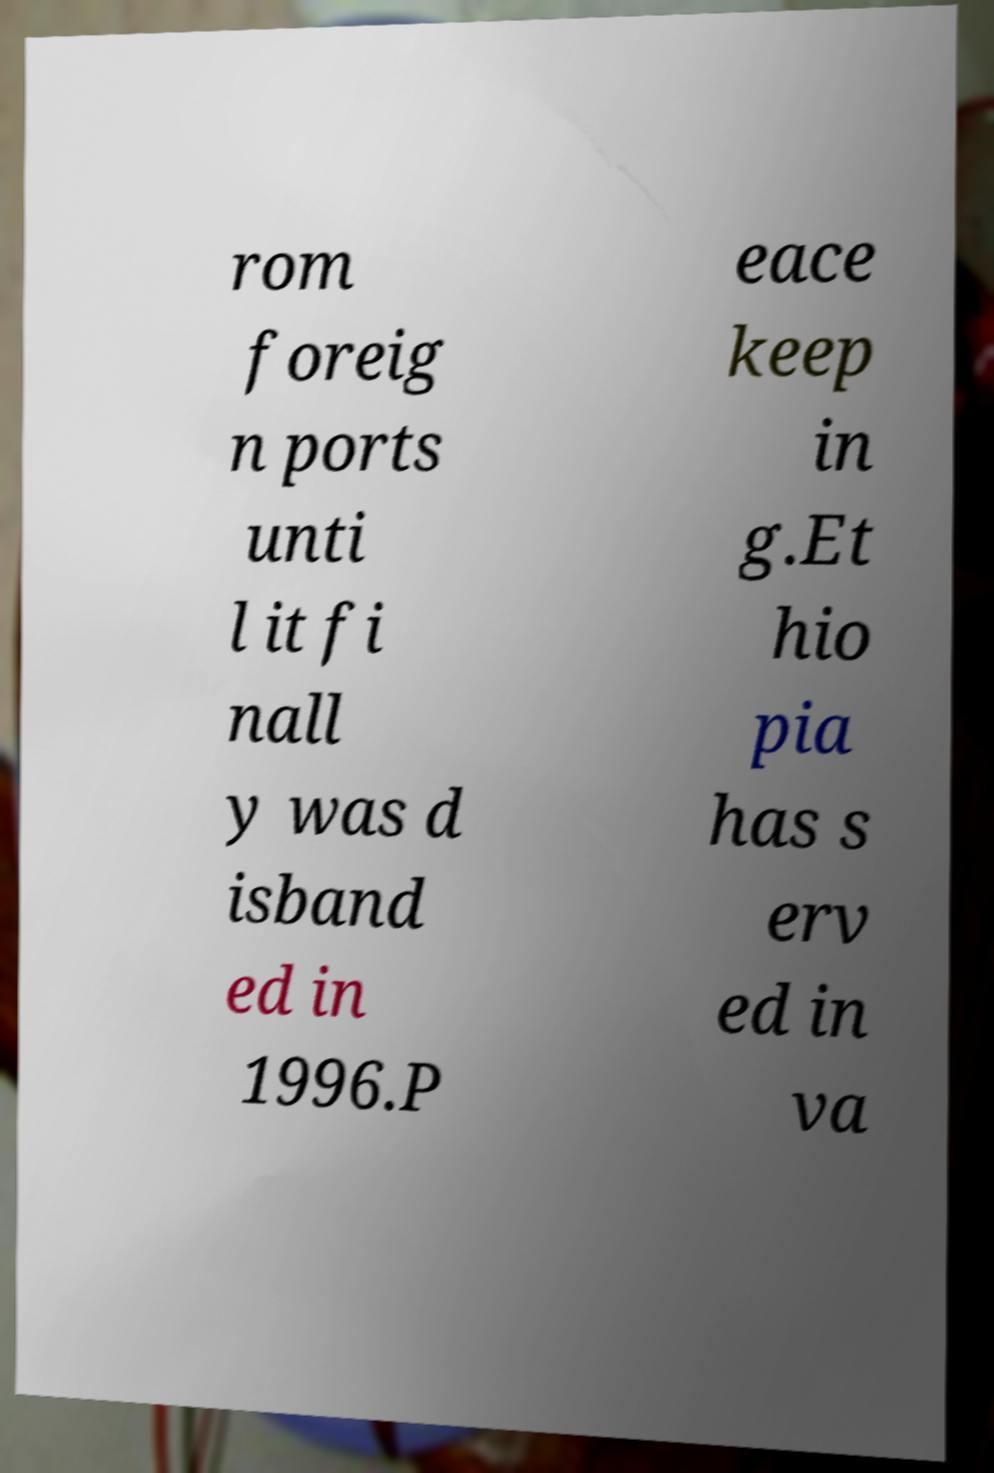Can you accurately transcribe the text from the provided image for me? rom foreig n ports unti l it fi nall y was d isband ed in 1996.P eace keep in g.Et hio pia has s erv ed in va 